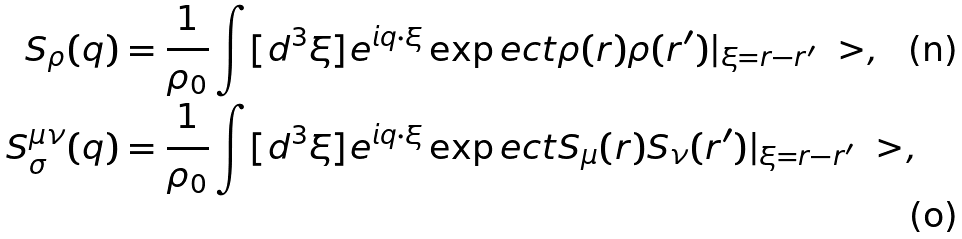<formula> <loc_0><loc_0><loc_500><loc_500>S _ { \rho } ( q ) = \frac { 1 } { \rho _ { 0 } } \int [ d ^ { 3 } \xi ] & e ^ { i q \cdot \xi } \exp e c t { \rho ( r ) \rho ( r ^ { \prime } ) } | _ { \xi = r - r ^ { \prime } } \ > , \\ S ^ { \mu \nu } _ { \sigma } ( q ) = \frac { 1 } { \rho _ { 0 } } \int [ d ^ { 3 } \xi ] & e ^ { i q \cdot \xi } \exp e c t { S _ { \mu } ( r ) S _ { \nu } ( r ^ { \prime } ) } | _ { \xi = r - r ^ { \prime } } \ > ,</formula> 